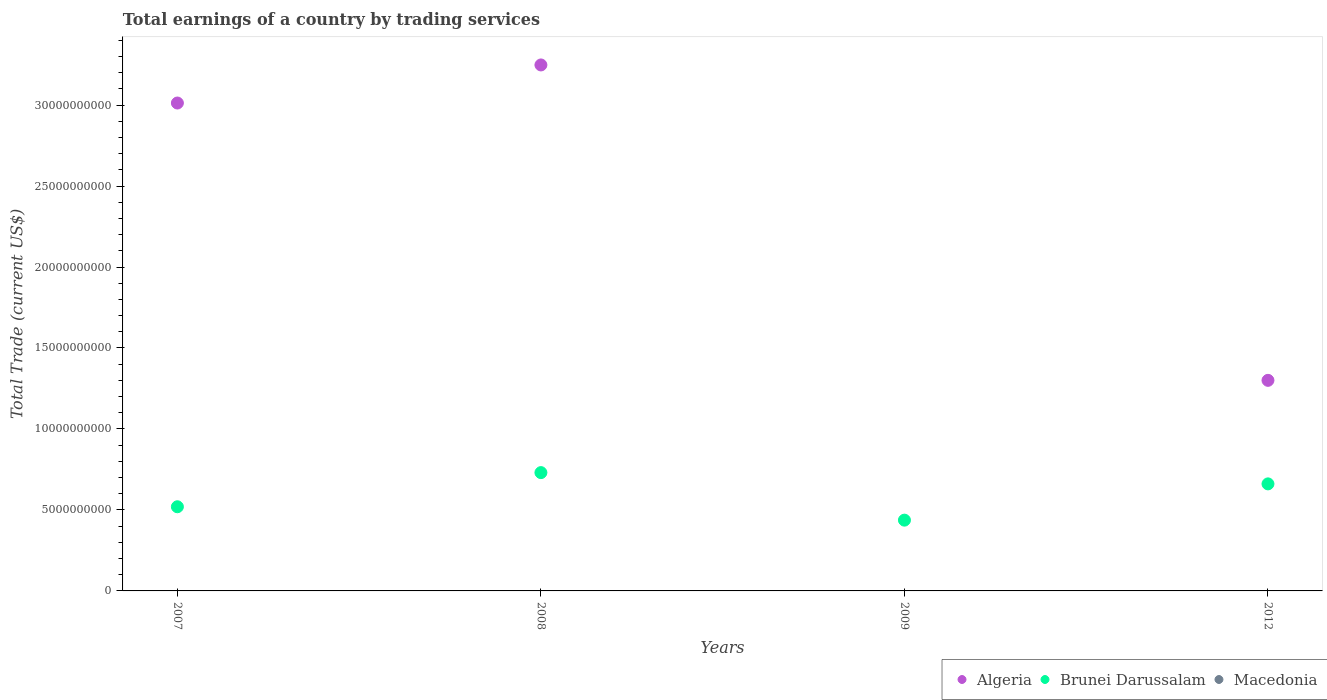How many different coloured dotlines are there?
Provide a short and direct response. 2. Across all years, what is the maximum total earnings in Algeria?
Your response must be concise. 3.25e+1. Across all years, what is the minimum total earnings in Algeria?
Provide a succinct answer. 0. In which year was the total earnings in Brunei Darussalam maximum?
Keep it short and to the point. 2008. What is the total total earnings in Algeria in the graph?
Ensure brevity in your answer.  7.56e+1. What is the difference between the total earnings in Algeria in 2007 and that in 2012?
Your answer should be very brief. 1.71e+1. What is the difference between the total earnings in Macedonia in 2012 and the total earnings in Brunei Darussalam in 2009?
Keep it short and to the point. -4.37e+09. What is the average total earnings in Brunei Darussalam per year?
Offer a terse response. 5.87e+09. In the year 2012, what is the difference between the total earnings in Brunei Darussalam and total earnings in Algeria?
Your answer should be very brief. -6.39e+09. What is the ratio of the total earnings in Algeria in 2007 to that in 2012?
Your response must be concise. 2.32. What is the difference between the highest and the second highest total earnings in Brunei Darussalam?
Your response must be concise. 6.96e+08. What is the difference between the highest and the lowest total earnings in Brunei Darussalam?
Give a very brief answer. 2.93e+09. In how many years, is the total earnings in Algeria greater than the average total earnings in Algeria taken over all years?
Provide a short and direct response. 2. Is it the case that in every year, the sum of the total earnings in Brunei Darussalam and total earnings in Macedonia  is greater than the total earnings in Algeria?
Offer a terse response. No. Does the total earnings in Algeria monotonically increase over the years?
Offer a terse response. No. How many dotlines are there?
Offer a terse response. 2. How many years are there in the graph?
Offer a very short reply. 4. What is the difference between two consecutive major ticks on the Y-axis?
Offer a terse response. 5.00e+09. Are the values on the major ticks of Y-axis written in scientific E-notation?
Your answer should be very brief. No. Does the graph contain any zero values?
Provide a succinct answer. Yes. Does the graph contain grids?
Offer a very short reply. No. How many legend labels are there?
Your answer should be compact. 3. What is the title of the graph?
Offer a very short reply. Total earnings of a country by trading services. Does "Tajikistan" appear as one of the legend labels in the graph?
Ensure brevity in your answer.  No. What is the label or title of the Y-axis?
Make the answer very short. Total Trade (current US$). What is the Total Trade (current US$) of Algeria in 2007?
Keep it short and to the point. 3.01e+1. What is the Total Trade (current US$) in Brunei Darussalam in 2007?
Ensure brevity in your answer.  5.20e+09. What is the Total Trade (current US$) of Macedonia in 2007?
Your response must be concise. 0. What is the Total Trade (current US$) in Algeria in 2008?
Offer a terse response. 3.25e+1. What is the Total Trade (current US$) in Brunei Darussalam in 2008?
Ensure brevity in your answer.  7.30e+09. What is the Total Trade (current US$) of Macedonia in 2008?
Provide a short and direct response. 0. What is the Total Trade (current US$) of Brunei Darussalam in 2009?
Provide a succinct answer. 4.37e+09. What is the Total Trade (current US$) in Algeria in 2012?
Your answer should be very brief. 1.30e+1. What is the Total Trade (current US$) of Brunei Darussalam in 2012?
Offer a very short reply. 6.61e+09. Across all years, what is the maximum Total Trade (current US$) in Algeria?
Give a very brief answer. 3.25e+1. Across all years, what is the maximum Total Trade (current US$) of Brunei Darussalam?
Keep it short and to the point. 7.30e+09. Across all years, what is the minimum Total Trade (current US$) in Brunei Darussalam?
Your answer should be compact. 4.37e+09. What is the total Total Trade (current US$) in Algeria in the graph?
Offer a terse response. 7.56e+1. What is the total Total Trade (current US$) in Brunei Darussalam in the graph?
Ensure brevity in your answer.  2.35e+1. What is the difference between the Total Trade (current US$) of Algeria in 2007 and that in 2008?
Provide a succinct answer. -2.35e+09. What is the difference between the Total Trade (current US$) of Brunei Darussalam in 2007 and that in 2008?
Your response must be concise. -2.11e+09. What is the difference between the Total Trade (current US$) of Brunei Darussalam in 2007 and that in 2009?
Give a very brief answer. 8.26e+08. What is the difference between the Total Trade (current US$) in Algeria in 2007 and that in 2012?
Offer a very short reply. 1.71e+1. What is the difference between the Total Trade (current US$) in Brunei Darussalam in 2007 and that in 2012?
Give a very brief answer. -1.41e+09. What is the difference between the Total Trade (current US$) of Brunei Darussalam in 2008 and that in 2009?
Your answer should be very brief. 2.93e+09. What is the difference between the Total Trade (current US$) of Algeria in 2008 and that in 2012?
Your response must be concise. 1.95e+1. What is the difference between the Total Trade (current US$) in Brunei Darussalam in 2008 and that in 2012?
Your answer should be very brief. 6.96e+08. What is the difference between the Total Trade (current US$) in Brunei Darussalam in 2009 and that in 2012?
Ensure brevity in your answer.  -2.24e+09. What is the difference between the Total Trade (current US$) in Algeria in 2007 and the Total Trade (current US$) in Brunei Darussalam in 2008?
Offer a very short reply. 2.28e+1. What is the difference between the Total Trade (current US$) in Algeria in 2007 and the Total Trade (current US$) in Brunei Darussalam in 2009?
Your answer should be very brief. 2.58e+1. What is the difference between the Total Trade (current US$) in Algeria in 2007 and the Total Trade (current US$) in Brunei Darussalam in 2012?
Give a very brief answer. 2.35e+1. What is the difference between the Total Trade (current US$) in Algeria in 2008 and the Total Trade (current US$) in Brunei Darussalam in 2009?
Ensure brevity in your answer.  2.81e+1. What is the difference between the Total Trade (current US$) in Algeria in 2008 and the Total Trade (current US$) in Brunei Darussalam in 2012?
Your answer should be very brief. 2.59e+1. What is the average Total Trade (current US$) of Algeria per year?
Keep it short and to the point. 1.89e+1. What is the average Total Trade (current US$) in Brunei Darussalam per year?
Ensure brevity in your answer.  5.87e+09. In the year 2007, what is the difference between the Total Trade (current US$) of Algeria and Total Trade (current US$) of Brunei Darussalam?
Keep it short and to the point. 2.49e+1. In the year 2008, what is the difference between the Total Trade (current US$) in Algeria and Total Trade (current US$) in Brunei Darussalam?
Your answer should be compact. 2.52e+1. In the year 2012, what is the difference between the Total Trade (current US$) of Algeria and Total Trade (current US$) of Brunei Darussalam?
Your answer should be compact. 6.39e+09. What is the ratio of the Total Trade (current US$) of Algeria in 2007 to that in 2008?
Ensure brevity in your answer.  0.93. What is the ratio of the Total Trade (current US$) in Brunei Darussalam in 2007 to that in 2008?
Ensure brevity in your answer.  0.71. What is the ratio of the Total Trade (current US$) of Brunei Darussalam in 2007 to that in 2009?
Your answer should be compact. 1.19. What is the ratio of the Total Trade (current US$) of Algeria in 2007 to that in 2012?
Make the answer very short. 2.32. What is the ratio of the Total Trade (current US$) in Brunei Darussalam in 2007 to that in 2012?
Keep it short and to the point. 0.79. What is the ratio of the Total Trade (current US$) in Brunei Darussalam in 2008 to that in 2009?
Provide a short and direct response. 1.67. What is the ratio of the Total Trade (current US$) in Algeria in 2008 to that in 2012?
Your response must be concise. 2.5. What is the ratio of the Total Trade (current US$) in Brunei Darussalam in 2008 to that in 2012?
Your answer should be compact. 1.11. What is the ratio of the Total Trade (current US$) of Brunei Darussalam in 2009 to that in 2012?
Your answer should be very brief. 0.66. What is the difference between the highest and the second highest Total Trade (current US$) in Algeria?
Offer a terse response. 2.35e+09. What is the difference between the highest and the second highest Total Trade (current US$) in Brunei Darussalam?
Give a very brief answer. 6.96e+08. What is the difference between the highest and the lowest Total Trade (current US$) in Algeria?
Offer a very short reply. 3.25e+1. What is the difference between the highest and the lowest Total Trade (current US$) of Brunei Darussalam?
Offer a terse response. 2.93e+09. 